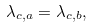<formula> <loc_0><loc_0><loc_500><loc_500>\lambda _ { c , a } = \lambda _ { c , b } ,</formula> 